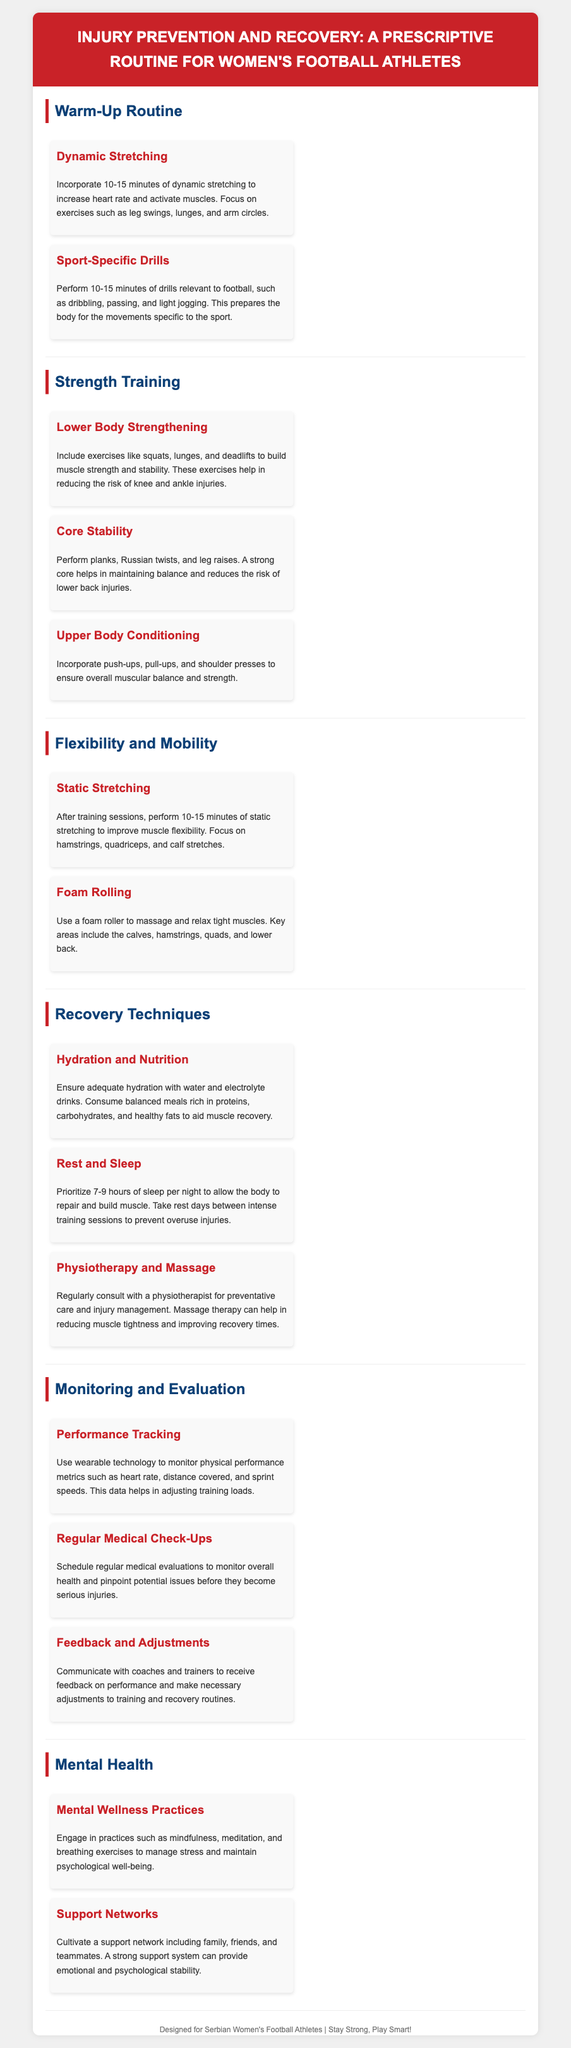What is the title of the document? The title is presented at the top of the document in the header section.
Answer: Injury Prevention and Recovery: A Prescriptive Routine for Women's Football Athletes How long should the warm-up routine last? The warm-up routine is specified to be between 10-15 minutes in the relevant sections.
Answer: 10-15 minutes What types of exercises are included in core stability training? The document lists specific exercises pertinent to core stability.
Answer: planks, Russian twists, and leg raises What should athletes focus on for static stretching? The content specifies particular muscle groups that need to be targeted during static stretching.
Answer: hamstrings, quadriceps, and calf stretches What is essential for recovery according to the document? The document outlines critical components necessary for effective recovery after training.
Answer: Hydration and Nutrition How many hours of sleep should athletes prioritize? The document explicitly mentions the recommended hours of sleep for muscle repair.
Answer: 7-9 hours What is one mental wellness practice recommended in the document? The document includes practices to maintain psychological well-being from the mental health section.
Answer: mindfulness What tracking technology can athletes use for performance monitoring? The document mentions a type of technology used for monitoring physical performance metrics.
Answer: wearable technology 